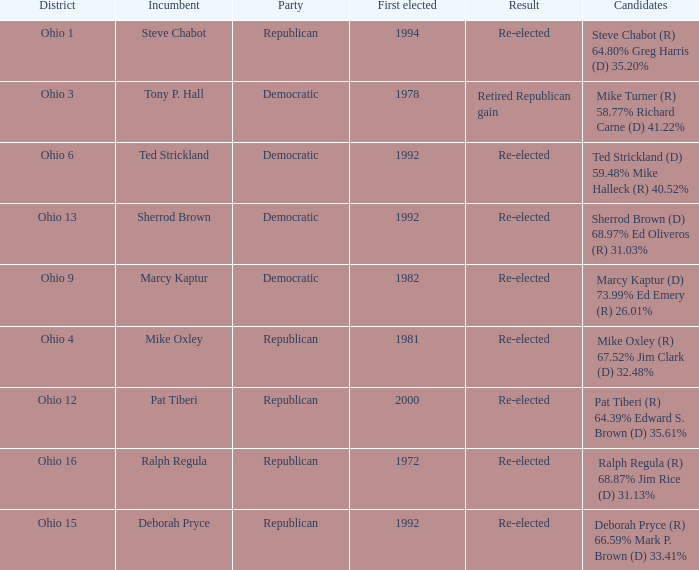In what district was the incumbent Steve Chabot?  Ohio 1. 